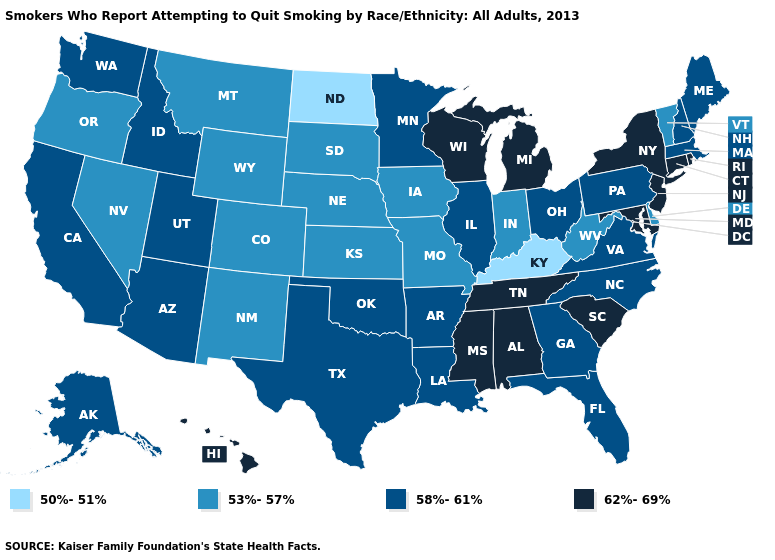Among the states that border North Carolina , which have the highest value?
Answer briefly. South Carolina, Tennessee. Name the states that have a value in the range 62%-69%?
Give a very brief answer. Alabama, Connecticut, Hawaii, Maryland, Michigan, Mississippi, New Jersey, New York, Rhode Island, South Carolina, Tennessee, Wisconsin. Does New Hampshire have the lowest value in the USA?
Be succinct. No. What is the highest value in the South ?
Keep it brief. 62%-69%. Among the states that border Ohio , does Pennsylvania have the lowest value?
Be succinct. No. Among the states that border Connecticut , does Rhode Island have the lowest value?
Concise answer only. No. Does Georgia have the same value as Nebraska?
Answer briefly. No. Which states have the lowest value in the South?
Write a very short answer. Kentucky. What is the value of Minnesota?
Write a very short answer. 58%-61%. Name the states that have a value in the range 62%-69%?
Answer briefly. Alabama, Connecticut, Hawaii, Maryland, Michigan, Mississippi, New Jersey, New York, Rhode Island, South Carolina, Tennessee, Wisconsin. What is the value of New Mexico?
Write a very short answer. 53%-57%. Name the states that have a value in the range 58%-61%?
Answer briefly. Alaska, Arizona, Arkansas, California, Florida, Georgia, Idaho, Illinois, Louisiana, Maine, Massachusetts, Minnesota, New Hampshire, North Carolina, Ohio, Oklahoma, Pennsylvania, Texas, Utah, Virginia, Washington. Which states have the highest value in the USA?
Answer briefly. Alabama, Connecticut, Hawaii, Maryland, Michigan, Mississippi, New Jersey, New York, Rhode Island, South Carolina, Tennessee, Wisconsin. What is the value of Iowa?
Be succinct. 53%-57%. What is the value of Arkansas?
Be succinct. 58%-61%. 